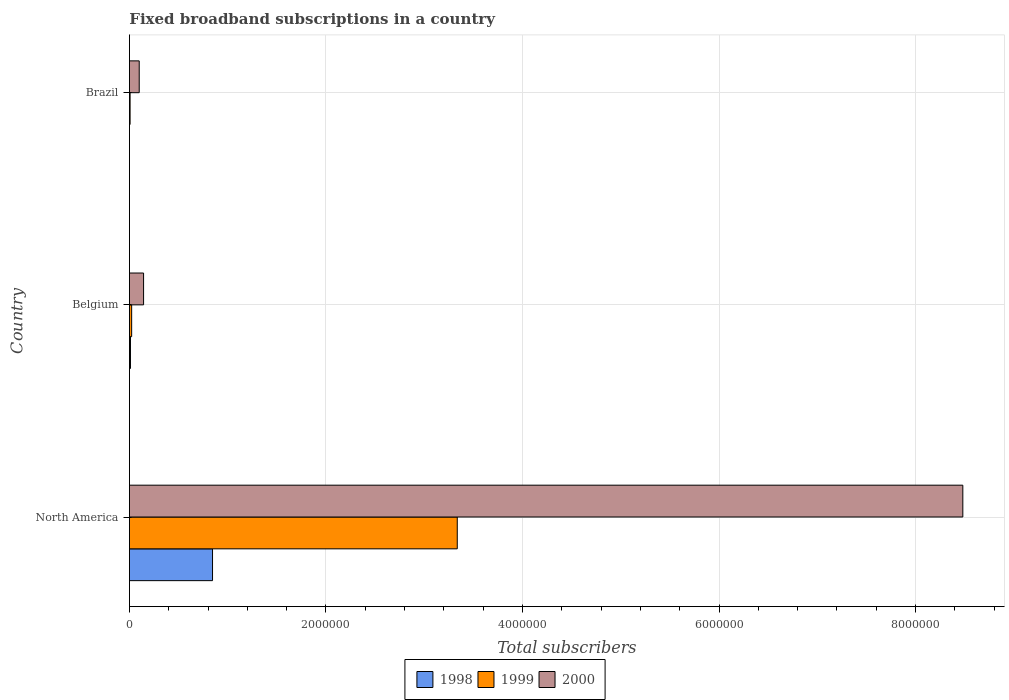How many groups of bars are there?
Your answer should be very brief. 3. Are the number of bars per tick equal to the number of legend labels?
Provide a short and direct response. Yes. Are the number of bars on each tick of the Y-axis equal?
Your answer should be very brief. Yes. How many bars are there on the 3rd tick from the top?
Your answer should be compact. 3. How many bars are there on the 1st tick from the bottom?
Ensure brevity in your answer.  3. What is the label of the 3rd group of bars from the top?
Give a very brief answer. North America. In how many cases, is the number of bars for a given country not equal to the number of legend labels?
Your answer should be compact. 0. What is the number of broadband subscriptions in 2000 in Belgium?
Offer a terse response. 1.44e+05. Across all countries, what is the maximum number of broadband subscriptions in 1999?
Provide a short and direct response. 3.34e+06. In which country was the number of broadband subscriptions in 1999 minimum?
Provide a short and direct response. Brazil. What is the total number of broadband subscriptions in 1998 in the graph?
Provide a succinct answer. 8.58e+05. What is the difference between the number of broadband subscriptions in 2000 in Belgium and that in Brazil?
Your response must be concise. 4.42e+04. What is the difference between the number of broadband subscriptions in 1999 in Brazil and the number of broadband subscriptions in 1998 in Belgium?
Provide a short and direct response. -3924. What is the average number of broadband subscriptions in 1998 per country?
Provide a short and direct response. 2.86e+05. What is the difference between the number of broadband subscriptions in 1998 and number of broadband subscriptions in 1999 in Belgium?
Your answer should be very brief. -1.21e+04. In how many countries, is the number of broadband subscriptions in 2000 greater than 4400000 ?
Offer a terse response. 1. What is the ratio of the number of broadband subscriptions in 1999 in Brazil to that in North America?
Your response must be concise. 0. Is the number of broadband subscriptions in 1998 in Brazil less than that in North America?
Offer a very short reply. Yes. What is the difference between the highest and the second highest number of broadband subscriptions in 1999?
Offer a very short reply. 3.31e+06. What is the difference between the highest and the lowest number of broadband subscriptions in 1999?
Your answer should be compact. 3.33e+06. Is the sum of the number of broadband subscriptions in 2000 in Brazil and North America greater than the maximum number of broadband subscriptions in 1999 across all countries?
Ensure brevity in your answer.  Yes. What does the 1st bar from the bottom in Belgium represents?
Your answer should be compact. 1998. How many countries are there in the graph?
Provide a succinct answer. 3. What is the difference between two consecutive major ticks on the X-axis?
Provide a succinct answer. 2.00e+06. Are the values on the major ticks of X-axis written in scientific E-notation?
Provide a short and direct response. No. Where does the legend appear in the graph?
Provide a succinct answer. Bottom center. How many legend labels are there?
Your answer should be compact. 3. What is the title of the graph?
Your answer should be compact. Fixed broadband subscriptions in a country. What is the label or title of the X-axis?
Your response must be concise. Total subscribers. What is the label or title of the Y-axis?
Give a very brief answer. Country. What is the Total subscribers in 1998 in North America?
Provide a short and direct response. 8.46e+05. What is the Total subscribers in 1999 in North America?
Offer a very short reply. 3.34e+06. What is the Total subscribers of 2000 in North America?
Offer a terse response. 8.48e+06. What is the Total subscribers of 1998 in Belgium?
Your response must be concise. 1.09e+04. What is the Total subscribers in 1999 in Belgium?
Give a very brief answer. 2.30e+04. What is the Total subscribers in 2000 in Belgium?
Your answer should be compact. 1.44e+05. What is the Total subscribers in 1998 in Brazil?
Offer a very short reply. 1000. What is the Total subscribers in 1999 in Brazil?
Your answer should be compact. 7000. What is the Total subscribers in 2000 in Brazil?
Keep it short and to the point. 1.00e+05. Across all countries, what is the maximum Total subscribers of 1998?
Offer a terse response. 8.46e+05. Across all countries, what is the maximum Total subscribers in 1999?
Ensure brevity in your answer.  3.34e+06. Across all countries, what is the maximum Total subscribers in 2000?
Your answer should be very brief. 8.48e+06. Across all countries, what is the minimum Total subscribers in 1998?
Keep it short and to the point. 1000. Across all countries, what is the minimum Total subscribers in 1999?
Offer a terse response. 7000. What is the total Total subscribers in 1998 in the graph?
Give a very brief answer. 8.58e+05. What is the total Total subscribers in 1999 in the graph?
Provide a succinct answer. 3.37e+06. What is the total Total subscribers of 2000 in the graph?
Ensure brevity in your answer.  8.73e+06. What is the difference between the Total subscribers in 1998 in North America and that in Belgium?
Provide a succinct answer. 8.35e+05. What is the difference between the Total subscribers of 1999 in North America and that in Belgium?
Make the answer very short. 3.31e+06. What is the difference between the Total subscribers in 2000 in North America and that in Belgium?
Give a very brief answer. 8.34e+06. What is the difference between the Total subscribers in 1998 in North America and that in Brazil?
Provide a succinct answer. 8.45e+05. What is the difference between the Total subscribers of 1999 in North America and that in Brazil?
Offer a terse response. 3.33e+06. What is the difference between the Total subscribers of 2000 in North America and that in Brazil?
Keep it short and to the point. 8.38e+06. What is the difference between the Total subscribers of 1998 in Belgium and that in Brazil?
Provide a succinct answer. 9924. What is the difference between the Total subscribers in 1999 in Belgium and that in Brazil?
Make the answer very short. 1.60e+04. What is the difference between the Total subscribers in 2000 in Belgium and that in Brazil?
Offer a terse response. 4.42e+04. What is the difference between the Total subscribers in 1998 in North America and the Total subscribers in 1999 in Belgium?
Give a very brief answer. 8.23e+05. What is the difference between the Total subscribers of 1998 in North America and the Total subscribers of 2000 in Belgium?
Ensure brevity in your answer.  7.02e+05. What is the difference between the Total subscribers in 1999 in North America and the Total subscribers in 2000 in Belgium?
Provide a succinct answer. 3.19e+06. What is the difference between the Total subscribers in 1998 in North America and the Total subscribers in 1999 in Brazil?
Offer a very short reply. 8.39e+05. What is the difference between the Total subscribers of 1998 in North America and the Total subscribers of 2000 in Brazil?
Keep it short and to the point. 7.46e+05. What is the difference between the Total subscribers of 1999 in North America and the Total subscribers of 2000 in Brazil?
Offer a terse response. 3.24e+06. What is the difference between the Total subscribers in 1998 in Belgium and the Total subscribers in 1999 in Brazil?
Provide a short and direct response. 3924. What is the difference between the Total subscribers of 1998 in Belgium and the Total subscribers of 2000 in Brazil?
Your answer should be compact. -8.91e+04. What is the difference between the Total subscribers in 1999 in Belgium and the Total subscribers in 2000 in Brazil?
Keep it short and to the point. -7.70e+04. What is the average Total subscribers in 1998 per country?
Provide a short and direct response. 2.86e+05. What is the average Total subscribers in 1999 per country?
Give a very brief answer. 1.12e+06. What is the average Total subscribers in 2000 per country?
Ensure brevity in your answer.  2.91e+06. What is the difference between the Total subscribers in 1998 and Total subscribers in 1999 in North America?
Provide a succinct answer. -2.49e+06. What is the difference between the Total subscribers of 1998 and Total subscribers of 2000 in North America?
Ensure brevity in your answer.  -7.63e+06. What is the difference between the Total subscribers in 1999 and Total subscribers in 2000 in North America?
Your answer should be very brief. -5.14e+06. What is the difference between the Total subscribers of 1998 and Total subscribers of 1999 in Belgium?
Give a very brief answer. -1.21e+04. What is the difference between the Total subscribers of 1998 and Total subscribers of 2000 in Belgium?
Your answer should be very brief. -1.33e+05. What is the difference between the Total subscribers in 1999 and Total subscribers in 2000 in Belgium?
Your response must be concise. -1.21e+05. What is the difference between the Total subscribers of 1998 and Total subscribers of 1999 in Brazil?
Provide a succinct answer. -6000. What is the difference between the Total subscribers of 1998 and Total subscribers of 2000 in Brazil?
Give a very brief answer. -9.90e+04. What is the difference between the Total subscribers in 1999 and Total subscribers in 2000 in Brazil?
Offer a terse response. -9.30e+04. What is the ratio of the Total subscribers of 1998 in North America to that in Belgium?
Your answer should be very brief. 77.44. What is the ratio of the Total subscribers in 1999 in North America to that in Belgium?
Provide a succinct answer. 145.06. What is the ratio of the Total subscribers in 2000 in North America to that in Belgium?
Keep it short and to the point. 58.81. What is the ratio of the Total subscribers of 1998 in North America to that in Brazil?
Offer a terse response. 845.9. What is the ratio of the Total subscribers of 1999 in North America to that in Brazil?
Give a very brief answer. 476.61. What is the ratio of the Total subscribers in 2000 in North America to that in Brazil?
Offer a very short reply. 84.81. What is the ratio of the Total subscribers of 1998 in Belgium to that in Brazil?
Offer a very short reply. 10.92. What is the ratio of the Total subscribers in 1999 in Belgium to that in Brazil?
Your answer should be very brief. 3.29. What is the ratio of the Total subscribers in 2000 in Belgium to that in Brazil?
Your answer should be very brief. 1.44. What is the difference between the highest and the second highest Total subscribers of 1998?
Keep it short and to the point. 8.35e+05. What is the difference between the highest and the second highest Total subscribers in 1999?
Give a very brief answer. 3.31e+06. What is the difference between the highest and the second highest Total subscribers of 2000?
Your response must be concise. 8.34e+06. What is the difference between the highest and the lowest Total subscribers in 1998?
Your answer should be very brief. 8.45e+05. What is the difference between the highest and the lowest Total subscribers in 1999?
Ensure brevity in your answer.  3.33e+06. What is the difference between the highest and the lowest Total subscribers of 2000?
Keep it short and to the point. 8.38e+06. 